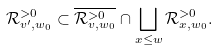<formula> <loc_0><loc_0><loc_500><loc_500>\mathcal { R } _ { v ^ { \prime } , w _ { 0 } } ^ { > 0 } \subset \overline { \mathcal { R } _ { v , w _ { 0 } } ^ { > 0 } } \cap \bigsqcup _ { x \leq w } \mathcal { R } _ { x , w _ { 0 } } ^ { > 0 } .</formula> 